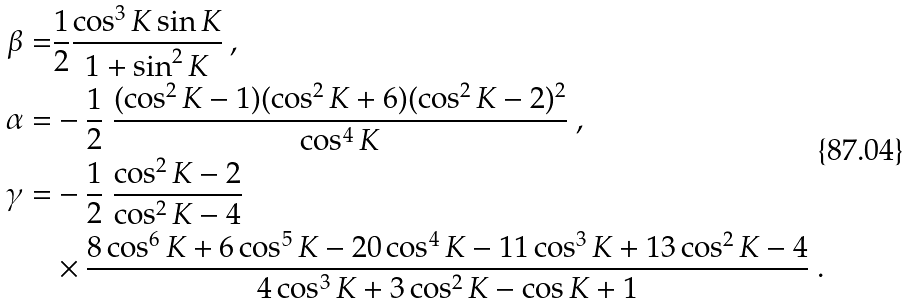<formula> <loc_0><loc_0><loc_500><loc_500>\beta = & \frac { 1 } { 2 } \frac { \cos ^ { 3 } K \sin K } { 1 + \sin ^ { 2 } K } \ , \\ \alpha = & - \frac { 1 } { 2 } \ \frac { ( \cos ^ { 2 } K - 1 ) ( \cos ^ { 2 } K + 6 ) ( \cos ^ { 2 } K - 2 ) ^ { 2 } } { \cos ^ { 4 } K } \ , \\ \gamma = & - \frac { 1 } { 2 } \ \frac { \cos ^ { 2 } K - 2 } { \cos ^ { 2 } K - 4 } \\ & \times \frac { 8 \cos ^ { 6 } K + 6 \cos ^ { 5 } K - 2 0 \cos ^ { 4 } K - 1 1 \cos ^ { 3 } K + 1 3 \cos ^ { 2 } K - 4 } { 4 \cos ^ { 3 } K + 3 \cos ^ { 2 } K - \cos K + 1 } \ .</formula> 